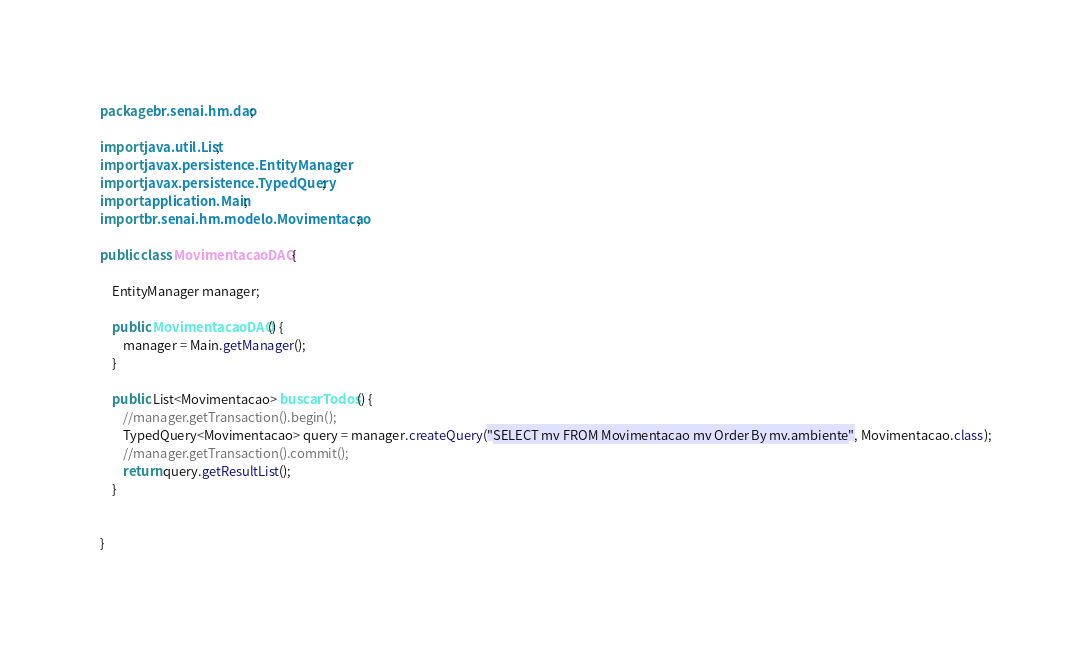<code> <loc_0><loc_0><loc_500><loc_500><_Java_>package br.senai.hm.dao;

import java.util.List;
import javax.persistence.EntityManager;
import javax.persistence.TypedQuery;
import application.Main;
import br.senai.hm.modelo.Movimentacao;

public class MovimentacaoDAO {
	
	EntityManager manager;
	
	public MovimentacaoDAO() {
		manager = Main.getManager();
	}
	
	public List<Movimentacao> buscarTodos() {
		//manager.getTransaction().begin();
		TypedQuery<Movimentacao> query = manager.createQuery("SELECT mv FROM Movimentacao mv Order By mv.ambiente", Movimentacao.class);
		//manager.getTransaction().commit();
		return query.getResultList();
	}
	

}
</code> 